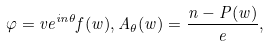Convert formula to latex. <formula><loc_0><loc_0><loc_500><loc_500>\varphi = v e ^ { i n \theta } f ( w ) , A _ { \theta } ( w ) = \frac { n - P ( w ) } { e } ,</formula> 